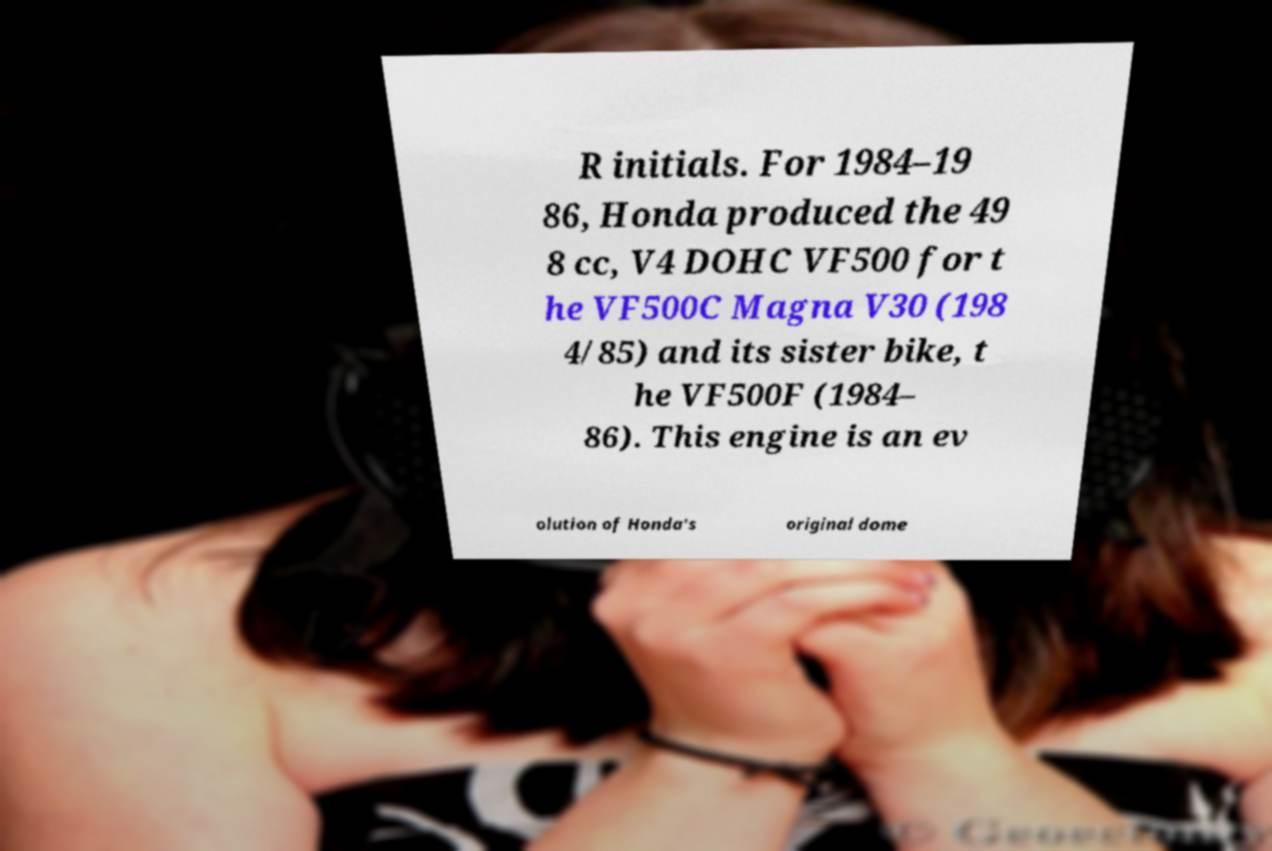There's text embedded in this image that I need extracted. Can you transcribe it verbatim? R initials. For 1984–19 86, Honda produced the 49 8 cc, V4 DOHC VF500 for t he VF500C Magna V30 (198 4/85) and its sister bike, t he VF500F (1984– 86). This engine is an ev olution of Honda's original dome 